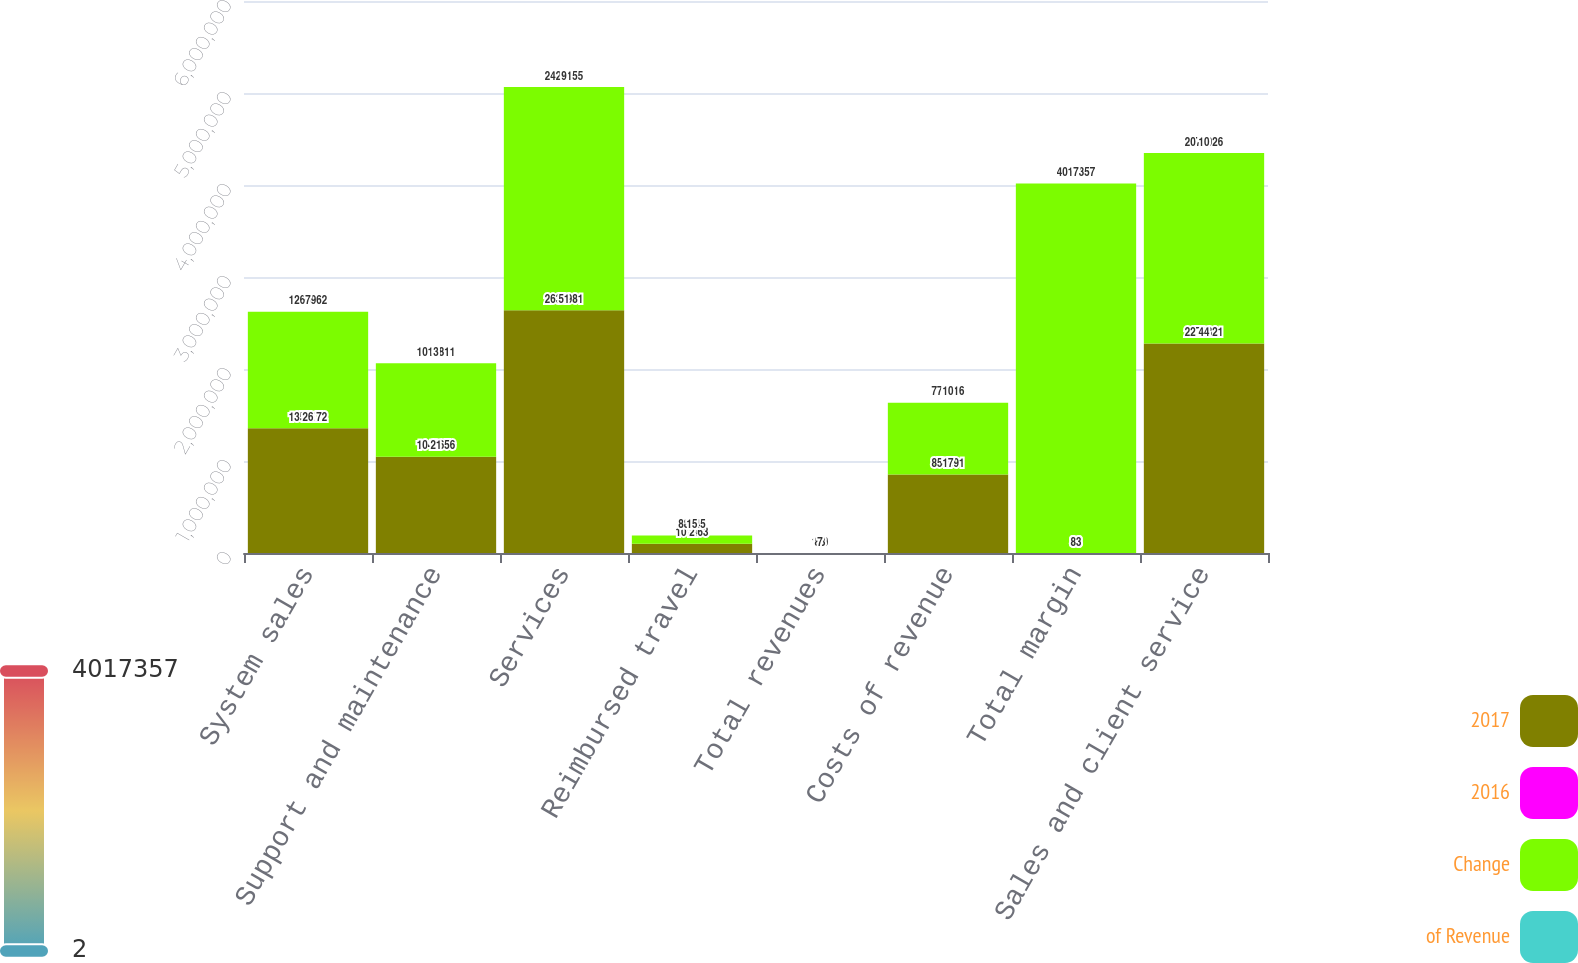<chart> <loc_0><loc_0><loc_500><loc_500><stacked_bar_chart><ecel><fcel>System sales<fcel>Support and maintenance<fcel>Services<fcel>Reimbursed travel<fcel>Total revenues<fcel>Costs of revenue<fcel>Total margin<fcel>Sales and client service<nl><fcel>2017<fcel>1.35517e+06<fcel>1.04666e+06<fcel>2.63898e+06<fcel>101463<fcel>83<fcel>854091<fcel>83<fcel>2.27682e+06<nl><fcel>2016<fcel>26<fcel>21<fcel>51<fcel>2<fcel>100<fcel>17<fcel>83<fcel>44<nl><fcel>Change<fcel>1.26596e+06<fcel>1.01581e+06<fcel>2.42616e+06<fcel>88545<fcel>83<fcel>779116<fcel>4.01736e+06<fcel>2.07193e+06<nl><fcel>of Revenue<fcel>7<fcel>3<fcel>9<fcel>15<fcel>7<fcel>10<fcel>7<fcel>10<nl></chart> 